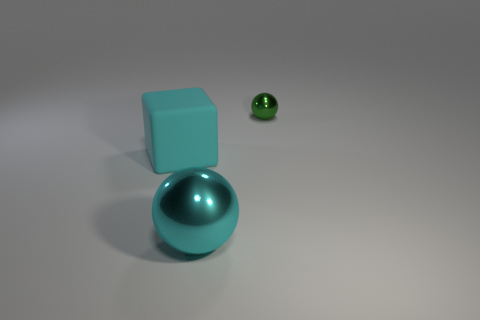Add 1 tiny green shiny objects. How many objects exist? 4 Subtract all cubes. How many objects are left? 2 Add 1 small green objects. How many small green objects are left? 2 Add 1 tiny yellow matte cubes. How many tiny yellow matte cubes exist? 1 Subtract 0 green cubes. How many objects are left? 3 Subtract all tiny green shiny balls. Subtract all small green balls. How many objects are left? 1 